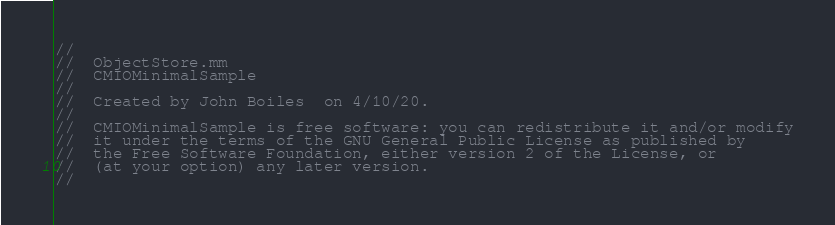<code> <loc_0><loc_0><loc_500><loc_500><_ObjectiveC_>//
//  ObjectStore.mm
//  CMIOMinimalSample
//
//  Created by John Boiles  on 4/10/20.
//
//  CMIOMinimalSample is free software: you can redistribute it and/or modify
//  it under the terms of the GNU General Public License as published by
//  the Free Software Foundation, either version 2 of the License, or
//  (at your option) any later version.
//</code> 